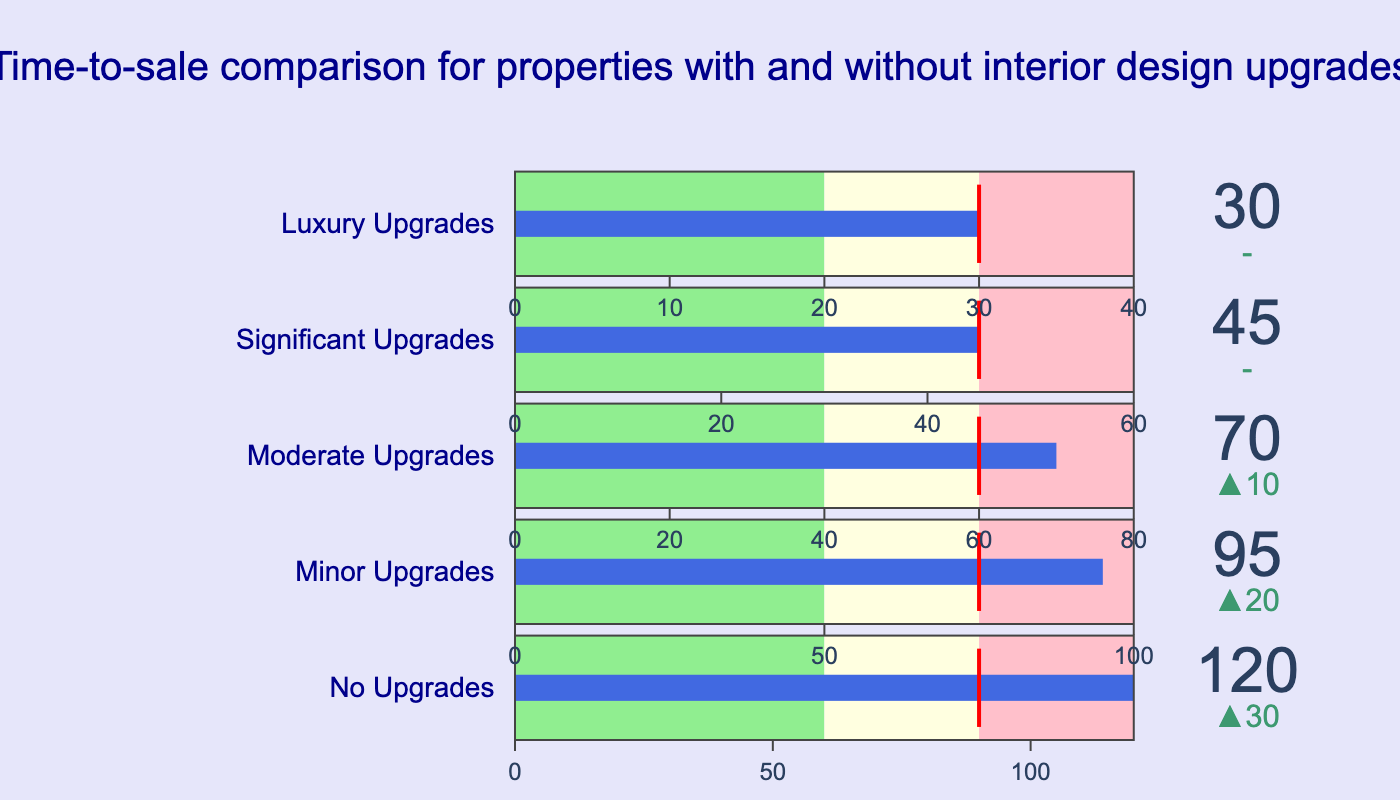how is the actual time-to-sale for properties with luxury upgrades compared to properties with significant upgrades? Properties with luxury upgrades have an actual time-to-sale of 30 days, while properties with significant upgrades have an actual time-to-sale of 45 days. So, properties with luxury upgrades sell faster.
Answer: 30 days faster Are there any categories where the actual time-to-sale meets the target? Properties with significant and luxury upgrades have actual times-to-sale that meet their targets. Both categories show actual values equal to their targets.
Answer: Yes, significant and luxury upgrades What is the target time-to-sale for properties with minor upgrades? The target time-to-sale for properties with minor upgrades is 75 days.
Answer: 75 days For properties with no upgrades, how much longer is the actual time-to-sale than the target? For properties with no upgrades, the actual time-to-sale is 120 days and the target is 90 days. The difference is 120 - 90 = 30 days.
Answer: 30 days Which category has the highest actual time-to-sale? The category with no upgrades has the highest actual time-to-sale at 120 days.
Answer: No upgrades How much faster do properties with moderate upgrades sell compared to properties with minor upgrades? Properties with moderate upgrades have an actual time-to-sale of 70 days, whereas properties with minor upgrades have an actual time-to-sale of 95 days. The difference is 95 - 70 = 25 days.
Answer: 25 days What color represents the range from 0 to the first range threshold in the gauge? The color representing the range from 0 to the first range threshold (Range1) in the gauge is light green.
Answer: Light green Is there any category where the actual time-to-sale is below the target, and by how much? No category has an actual time-to-sale below its target. All actual values are either at or above their targets.
Answer: No What is the range for significant upgrades? The significant upgrades category has a range from 0 to 60 days, with the target set at 45 days.
Answer: 0 to 60 days What can you infer about the effectiveness of interior design upgrades in reducing time-to-sale? As the level of interior design upgrades increases from no upgrades to luxury upgrades, the actual time-to-sale decreases. This indicates a clear correlation where more significant interior design upgrades lead to properties selling faster.
Answer: More upgrades, faster sales 